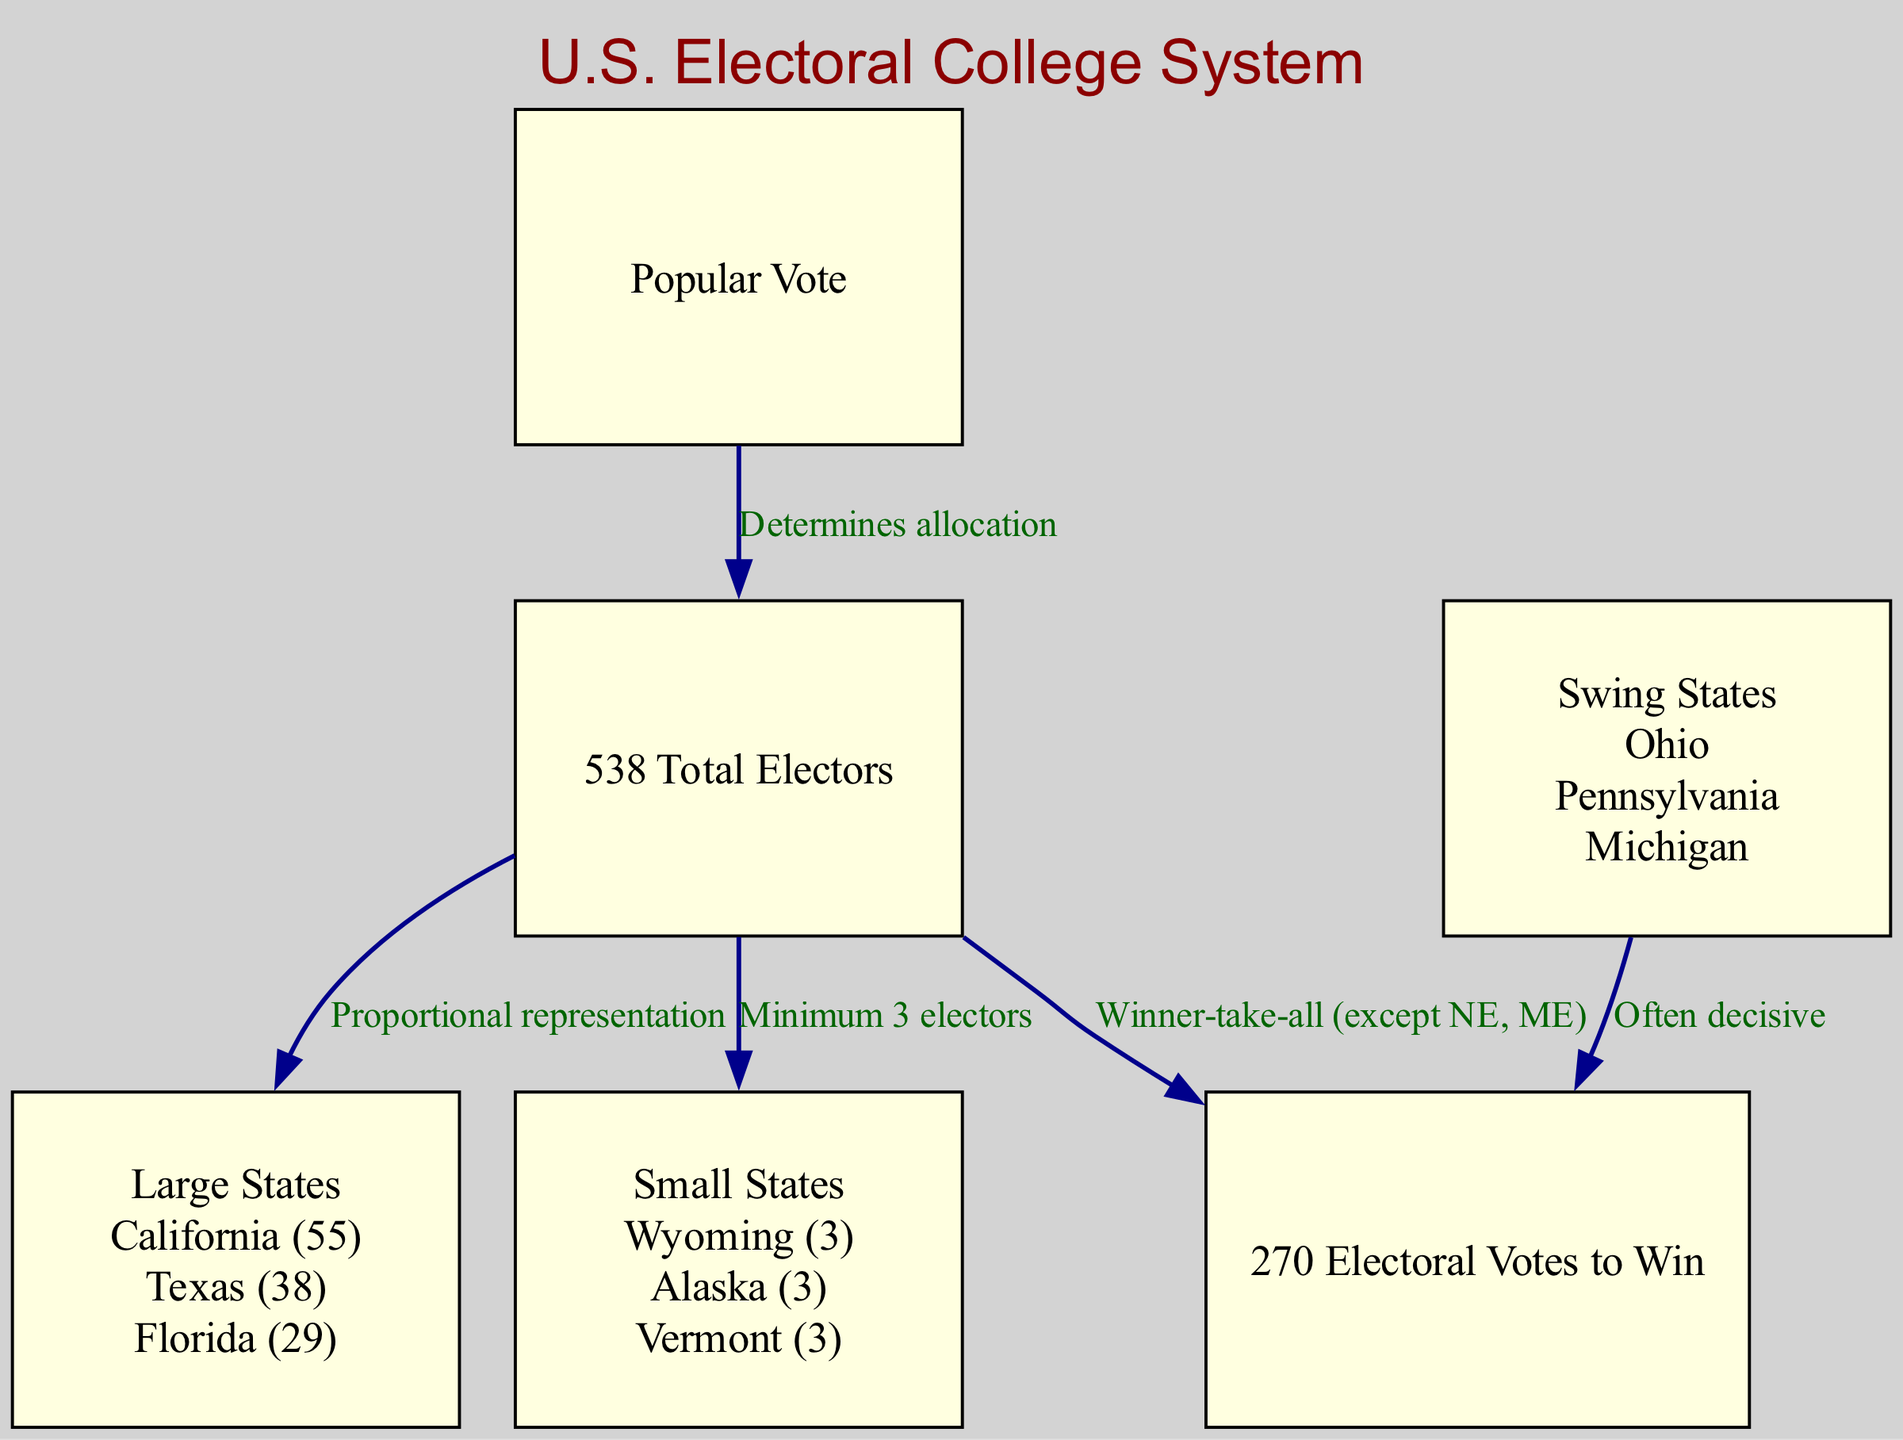What is the total number of electors in the U.S. Electoral College? The diagram indicates that there are 538 total electors in the U.S. Electoral College, as stated directly in the "538 Total Electors" node.
Answer: 538 Which state has the most electors? According to the examples provided under the "Large States" node, California has the most electors with a total of 55.
Answer: California (55) What term describes states like Ohio, Pennsylvania, and Michigan? These states are highlighted in the "Swing States" node, indicating that they are often decisive in elections due to their voting patterns.
Answer: Swing States What is required to win the presidency? The diagram specifies that a candidate must secure 270 electoral votes in order to win the presidency, as indicated in the "270 Electoral Votes to Win" node.
Answer: 270 Electoral Votes to Win What type of states is guaranteed a minimum of three electors? The "Small States" node mentions that these states, which include examples like Wyoming and Vermont, are guaranteed a minimum of three electors regardless of their population.
Answer: Small States How do electors from large states correlate to overall representation? The edge labeled "Proportional representation" connecting "538 Total Electors" to "Large States" indicates that the number of electors is proportionate to the population of these larger states.
Answer: Proportional representation What voting approach is primarily used in the Electoral College? The edge connecting "538 Total Electors" to "270 Electoral Votes to Win" is labeled "Winner-take-all (except NE, ME)", indicating that most states use a winner-take-all system for allocating electors.
Answer: Winner-take-all Which group of states is crucial for determining the election outcome? The arrow from "Swing States" to "270 Electoral Votes to Win" labeled "Often decisive" signifies that these states play a critical role in deciding the election results.
Answer: Swing States How does the popular vote influence electors? The edge from the "Popular Vote" to "538 Total Electors" labeled "Determines allocation" implies that the popular vote results in each state determine how many electors each candidate receives.
Answer: Determines allocation 